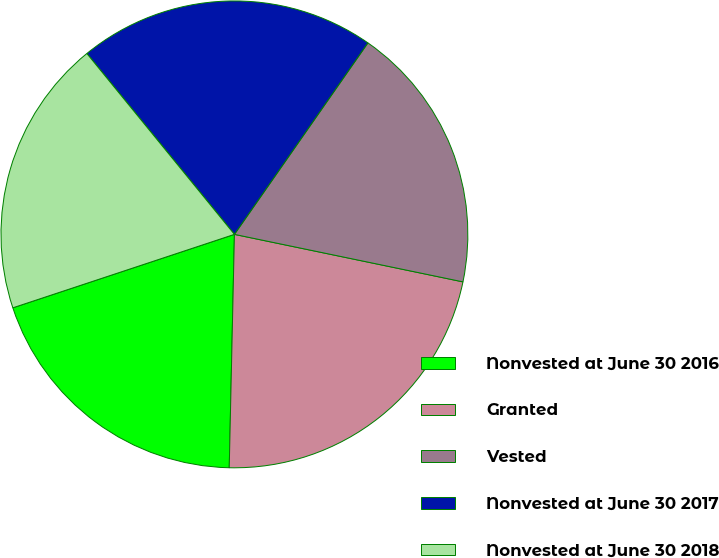Convert chart to OTSL. <chart><loc_0><loc_0><loc_500><loc_500><pie_chart><fcel>Nonvested at June 30 2016<fcel>Granted<fcel>Vested<fcel>Nonvested at June 30 2017<fcel>Nonvested at June 30 2018<nl><fcel>19.55%<fcel>22.09%<fcel>18.57%<fcel>20.58%<fcel>19.2%<nl></chart> 